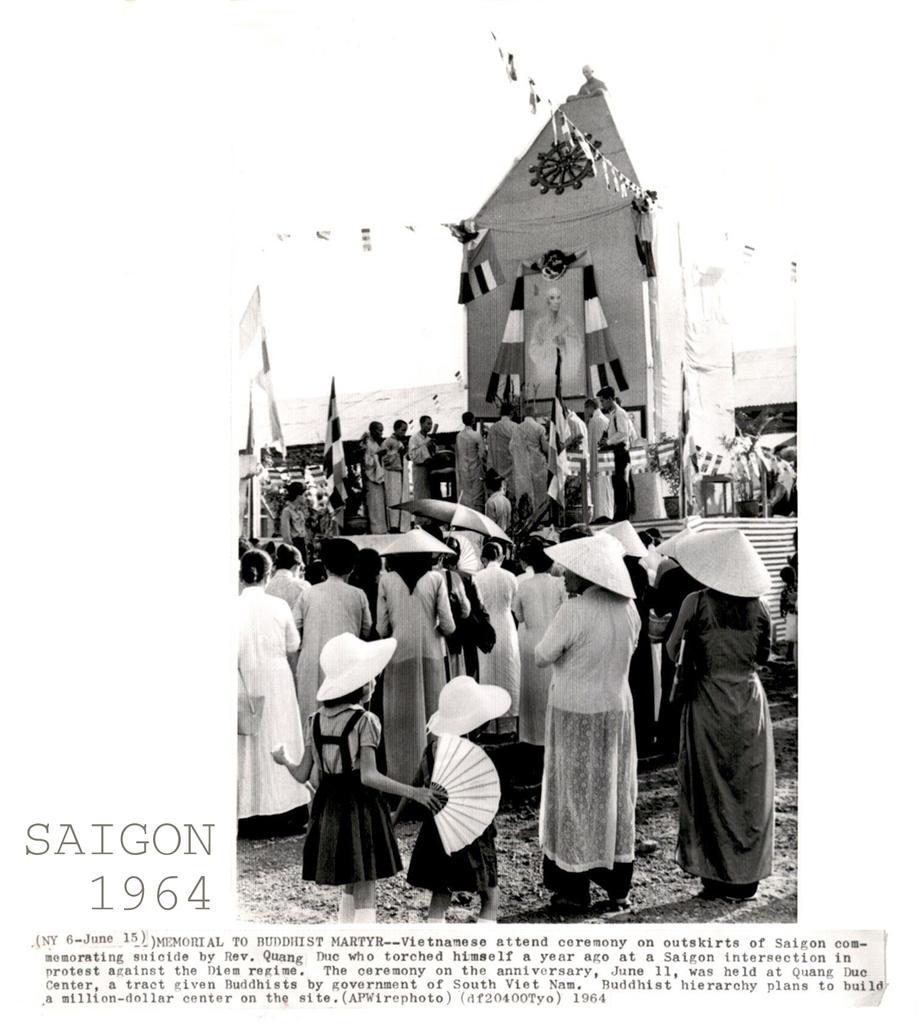Can you describe this image briefly? This is a poster having an image and texts. In this image, we can see there are persons, some of them are wearing caps, there is a tent, a shelter and the sky. 